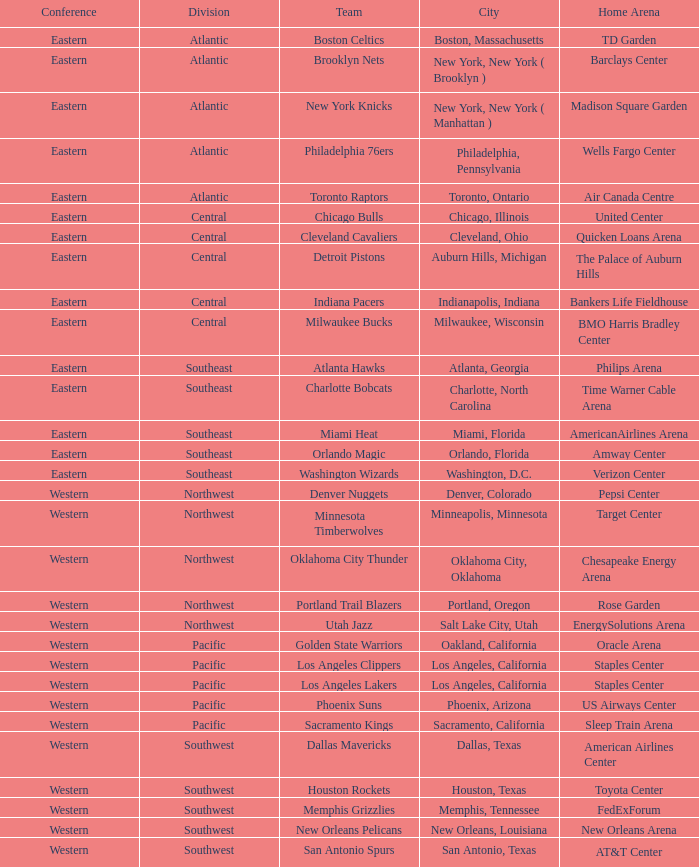To which division do the toronto raptors pertain? Atlantic. I'm looking to parse the entire table for insights. Could you assist me with that? {'header': ['Conference', 'Division', 'Team', 'City', 'Home Arena'], 'rows': [['Eastern', 'Atlantic', 'Boston Celtics', 'Boston, Massachusetts', 'TD Garden'], ['Eastern', 'Atlantic', 'Brooklyn Nets', 'New York, New York ( Brooklyn )', 'Barclays Center'], ['Eastern', 'Atlantic', 'New York Knicks', 'New York, New York ( Manhattan )', 'Madison Square Garden'], ['Eastern', 'Atlantic', 'Philadelphia 76ers', 'Philadelphia, Pennsylvania', 'Wells Fargo Center'], ['Eastern', 'Atlantic', 'Toronto Raptors', 'Toronto, Ontario', 'Air Canada Centre'], ['Eastern', 'Central', 'Chicago Bulls', 'Chicago, Illinois', 'United Center'], ['Eastern', 'Central', 'Cleveland Cavaliers', 'Cleveland, Ohio', 'Quicken Loans Arena'], ['Eastern', 'Central', 'Detroit Pistons', 'Auburn Hills, Michigan', 'The Palace of Auburn Hills'], ['Eastern', 'Central', 'Indiana Pacers', 'Indianapolis, Indiana', 'Bankers Life Fieldhouse'], ['Eastern', 'Central', 'Milwaukee Bucks', 'Milwaukee, Wisconsin', 'BMO Harris Bradley Center'], ['Eastern', 'Southeast', 'Atlanta Hawks', 'Atlanta, Georgia', 'Philips Arena'], ['Eastern', 'Southeast', 'Charlotte Bobcats', 'Charlotte, North Carolina', 'Time Warner Cable Arena'], ['Eastern', 'Southeast', 'Miami Heat', 'Miami, Florida', 'AmericanAirlines Arena'], ['Eastern', 'Southeast', 'Orlando Magic', 'Orlando, Florida', 'Amway Center'], ['Eastern', 'Southeast', 'Washington Wizards', 'Washington, D.C.', 'Verizon Center'], ['Western', 'Northwest', 'Denver Nuggets', 'Denver, Colorado', 'Pepsi Center'], ['Western', 'Northwest', 'Minnesota Timberwolves', 'Minneapolis, Minnesota', 'Target Center'], ['Western', 'Northwest', 'Oklahoma City Thunder', 'Oklahoma City, Oklahoma', 'Chesapeake Energy Arena'], ['Western', 'Northwest', 'Portland Trail Blazers', 'Portland, Oregon', 'Rose Garden'], ['Western', 'Northwest', 'Utah Jazz', 'Salt Lake City, Utah', 'EnergySolutions Arena'], ['Western', 'Pacific', 'Golden State Warriors', 'Oakland, California', 'Oracle Arena'], ['Western', 'Pacific', 'Los Angeles Clippers', 'Los Angeles, California', 'Staples Center'], ['Western', 'Pacific', 'Los Angeles Lakers', 'Los Angeles, California', 'Staples Center'], ['Western', 'Pacific', 'Phoenix Suns', 'Phoenix, Arizona', 'US Airways Center'], ['Western', 'Pacific', 'Sacramento Kings', 'Sacramento, California', 'Sleep Train Arena'], ['Western', 'Southwest', 'Dallas Mavericks', 'Dallas, Texas', 'American Airlines Center'], ['Western', 'Southwest', 'Houston Rockets', 'Houston, Texas', 'Toyota Center'], ['Western', 'Southwest', 'Memphis Grizzlies', 'Memphis, Tennessee', 'FedExForum'], ['Western', 'Southwest', 'New Orleans Pelicans', 'New Orleans, Louisiana', 'New Orleans Arena'], ['Western', 'Southwest', 'San Antonio Spurs', 'San Antonio, Texas', 'AT&T Center']]} 